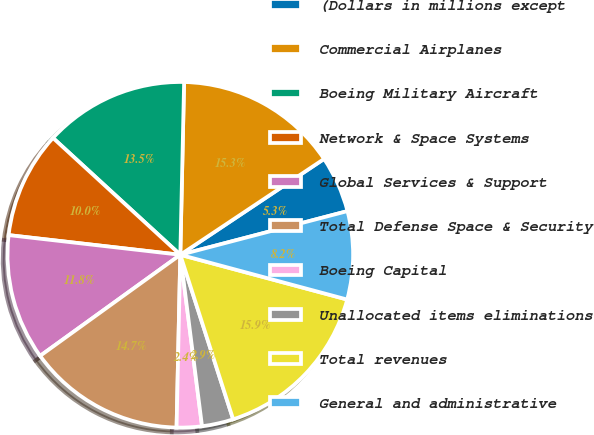<chart> <loc_0><loc_0><loc_500><loc_500><pie_chart><fcel>(Dollars in millions except<fcel>Commercial Airplanes<fcel>Boeing Military Aircraft<fcel>Network & Space Systems<fcel>Global Services & Support<fcel>Total Defense Space & Security<fcel>Boeing Capital<fcel>Unallocated items eliminations<fcel>Total revenues<fcel>General and administrative<nl><fcel>5.29%<fcel>15.29%<fcel>13.53%<fcel>10.0%<fcel>11.76%<fcel>14.71%<fcel>2.35%<fcel>2.94%<fcel>15.88%<fcel>8.24%<nl></chart> 